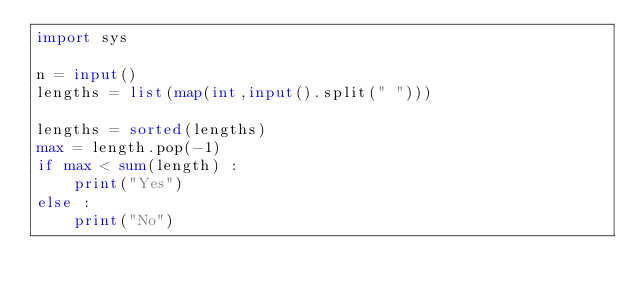Convert code to text. <code><loc_0><loc_0><loc_500><loc_500><_Python_>import sys

n = input()
lengths = list(map(int,input().split(" ")))

lengths = sorted(lengths)
max = length.pop(-1)
if max < sum(length) :
    print("Yes")
else :
    print("No")</code> 